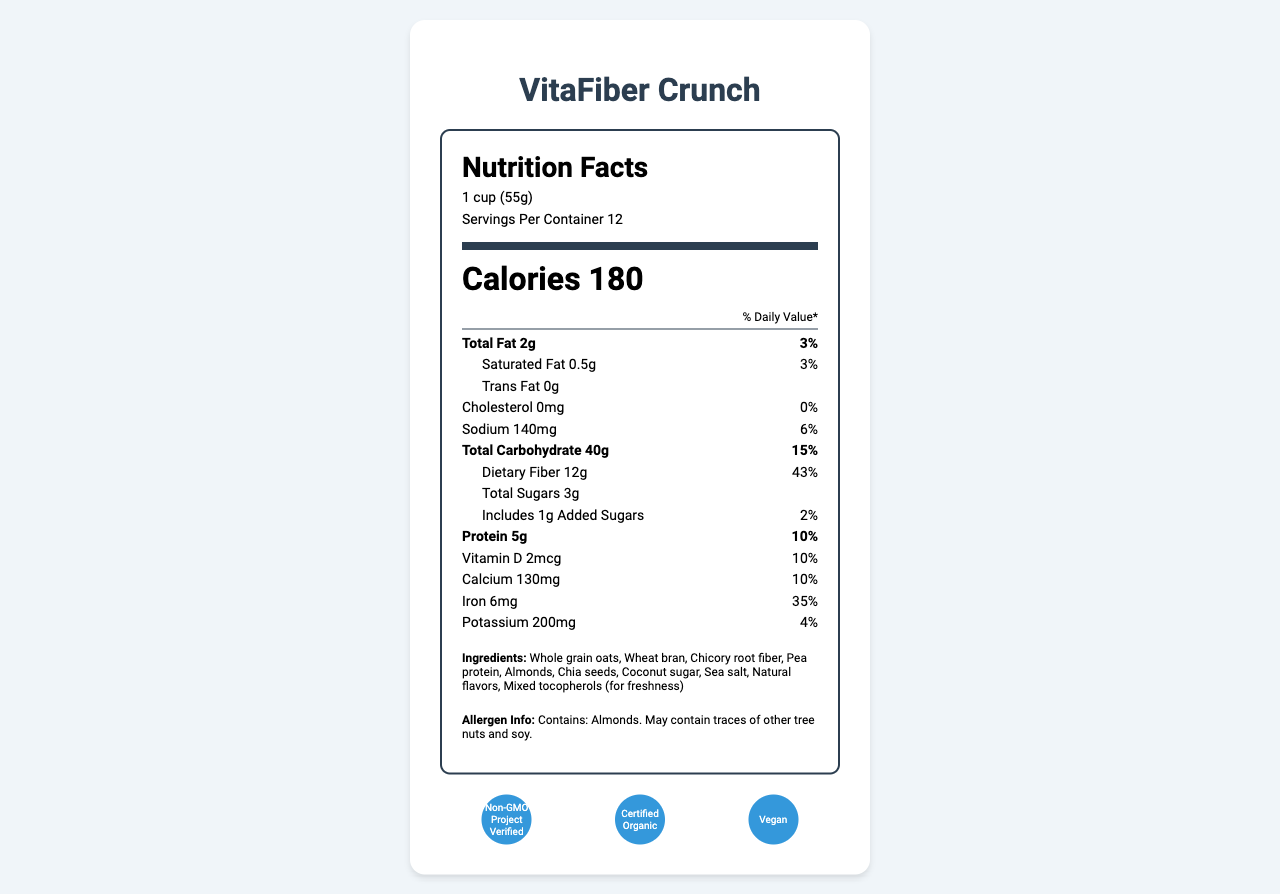what is the product name? The product name is clearly displayed at the top of the document.
Answer: VitaFiber Crunch How many servings are in the container? The document states "Servings Per Container 12" in the serving information section.
Answer: 12 How many grams of dietary fiber does each serving contain? The amount of dietary fiber per serving is listed as 12g in the nutrient section.
Answer: 12g Is there any trans fat in the cereal? The document mentions "Trans Fat 0g" in the nutrient section.
Answer: No What certifications does this cereal have? The certifications are listed in the certifications section.
Answer: Non-GMO Project Verified, Certified Organic, Vegan How many calories are there per serving? The number of calories per serving is displayed prominently in the document.
Answer: 180 What percentage of the daily value of iron does one serving provide? A. 10% B. 35% C. 25% The document states that one serving provides 35% of the daily value for iron.
Answer: B. 35% Which ingredient is listed first? A. Almonds B. Whole grain oats C. Pea protein Ingredients are listed by quantity in descending order, and the first listed is "Whole grain oats".
Answer: B. Whole grain oats Does this cereal support digestive health? The marketing claims include "Supports digestive health," indicating that the cereal supports digestive health.
Answer: Yes Summarize the main nutritional characteristics of this cereal. The explanation walks through the key nutritional information provided in the document and summarizes the highlighted nutritional characteristics and certifications.
Answer: The cereal VitaFiber Crunch is low in sugar, high in fiber, and a good source of protein. It has 180 calories per serving, 2g of total fat, 12g of dietary fiber, 3g of total sugars (including 1g of added sugars), 5g of protein, and significant amounts of iron (35% DV) and calcium (10% DV). It also has certifications such as Non-GMO Project Verified, Certified Organic, and Vegan, and claims to support digestive and heart health. What is the percentage daily value of Vitamin D per serving? The percentage daily value for Vitamin D per serving is listed as 10% in the nutrient section.
Answer: 10% What are the ingredients in this cereal? The list of ingredients is clearly presented in the ingredients section.
Answer: Whole grain oats, Wheat bran, Chicory root fiber, Pea protein, Almonds, Chia seeds, Coconut sugar, Sea salt, Natural flavors, Mixed tocopherols (for freshness) Which demographic is the target audience for this cereal? The target audience is specified as health-conscious consumers aged 25-55, particularly those interested in weight management, digestive health, and overall wellness.
Answer: Health-conscious consumers aged 25-55 What information is provided on the certifications for the cereal? The certifications section lists these three certifications.
Answer: The cereal is Non-GMO Project Verified, Certified Organic, and Vegan. Is the information sufficient to determine the shelf life of the cereal? The document does not provide any details related to the shelf life of the cereal.
Answer: Not enough information What is the unique selling proposition of VitaFiber Crunch compared to other cereals? This information is found in the competitive advantage section of the document.
Answer: VitaFiber Crunch contains 3 times more fiber and 70% less sugar than the average breakfast cereal, making it an ideal choice for consumers looking to improve their diet without sacrificing taste or convenience. 